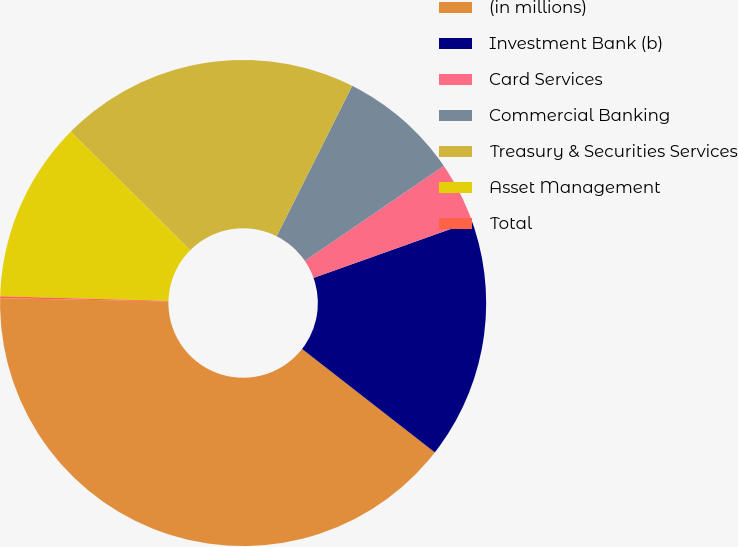Convert chart to OTSL. <chart><loc_0><loc_0><loc_500><loc_500><pie_chart><fcel>(in millions)<fcel>Investment Bank (b)<fcel>Card Services<fcel>Commercial Banking<fcel>Treasury & Securities Services<fcel>Asset Management<fcel>Total<nl><fcel>39.79%<fcel>15.99%<fcel>4.09%<fcel>8.05%<fcel>19.95%<fcel>12.02%<fcel>0.12%<nl></chart> 